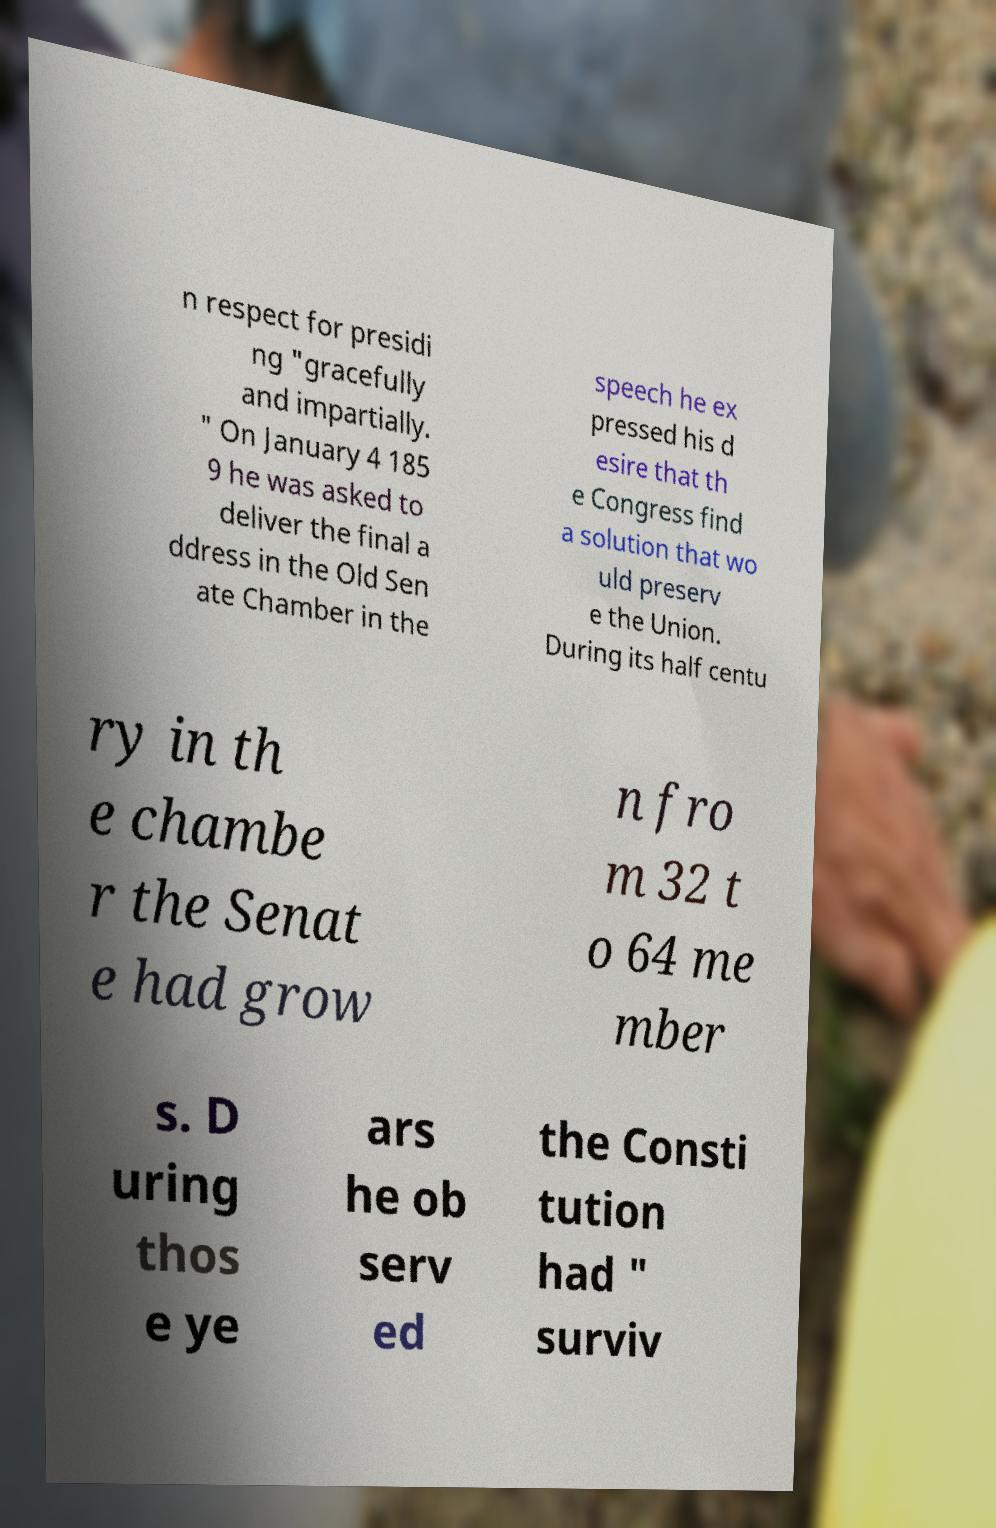For documentation purposes, I need the text within this image transcribed. Could you provide that? n respect for presidi ng "gracefully and impartially. " On January 4 185 9 he was asked to deliver the final a ddress in the Old Sen ate Chamber in the speech he ex pressed his d esire that th e Congress find a solution that wo uld preserv e the Union. During its half centu ry in th e chambe r the Senat e had grow n fro m 32 t o 64 me mber s. D uring thos e ye ars he ob serv ed the Consti tution had " surviv 